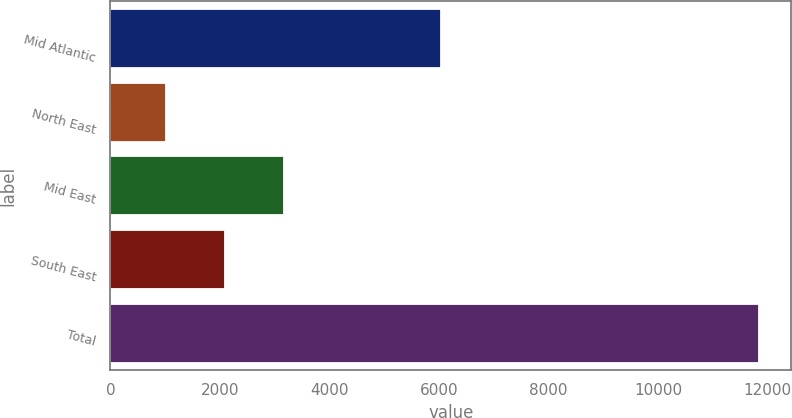Convert chart to OTSL. <chart><loc_0><loc_0><loc_500><loc_500><bar_chart><fcel>Mid Atlantic<fcel>North East<fcel>Mid East<fcel>South East<fcel>Total<nl><fcel>6029<fcel>1013<fcel>3177.2<fcel>2095.1<fcel>11834<nl></chart> 